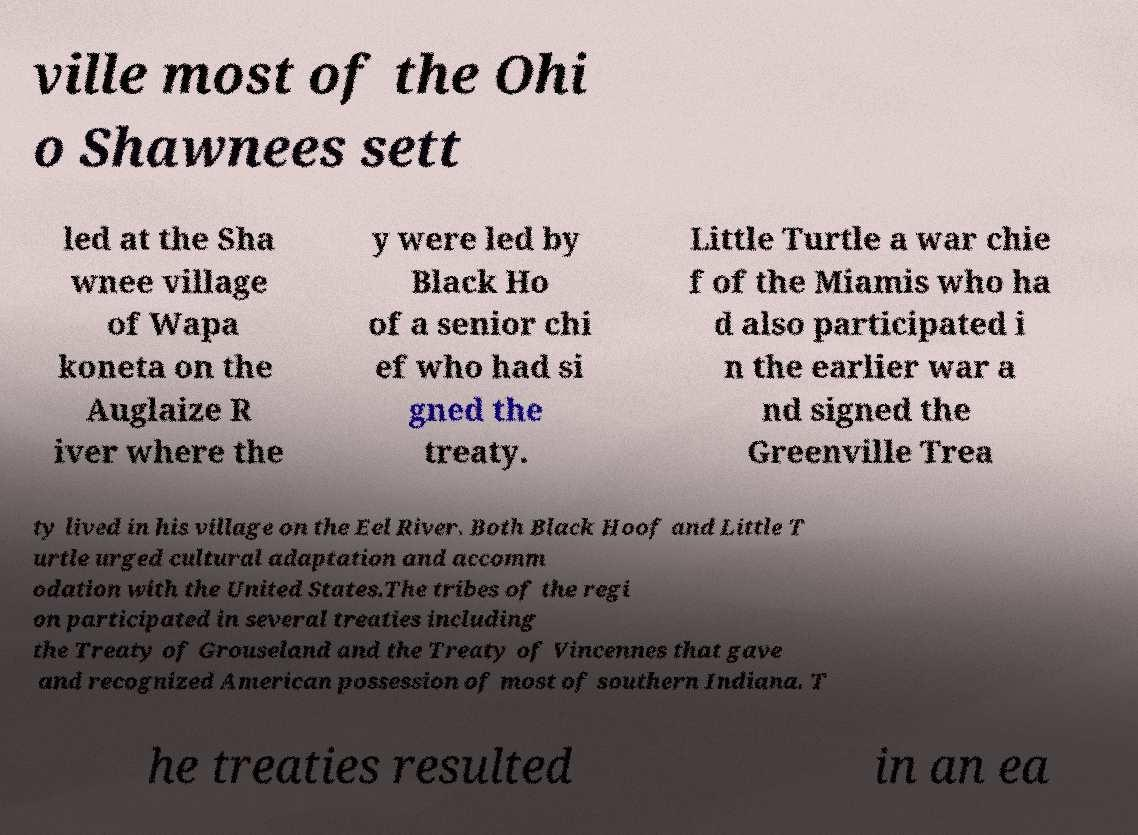I need the written content from this picture converted into text. Can you do that? ville most of the Ohi o Shawnees sett led at the Sha wnee village of Wapa koneta on the Auglaize R iver where the y were led by Black Ho of a senior chi ef who had si gned the treaty. Little Turtle a war chie f of the Miamis who ha d also participated i n the earlier war a nd signed the Greenville Trea ty lived in his village on the Eel River. Both Black Hoof and Little T urtle urged cultural adaptation and accomm odation with the United States.The tribes of the regi on participated in several treaties including the Treaty of Grouseland and the Treaty of Vincennes that gave and recognized American possession of most of southern Indiana. T he treaties resulted in an ea 